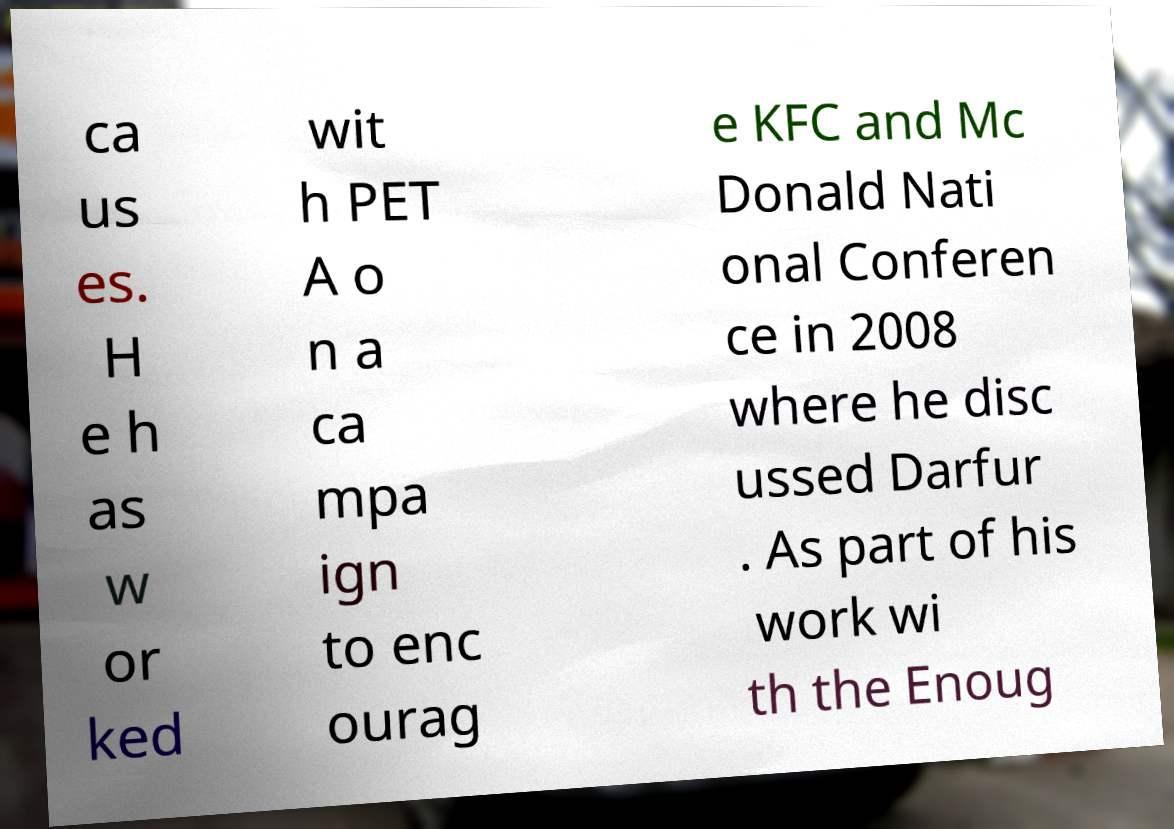I need the written content from this picture converted into text. Can you do that? ca us es. H e h as w or ked wit h PET A o n a ca mpa ign to enc ourag e KFC and Mc Donald Nati onal Conferen ce in 2008 where he disc ussed Darfur . As part of his work wi th the Enoug 